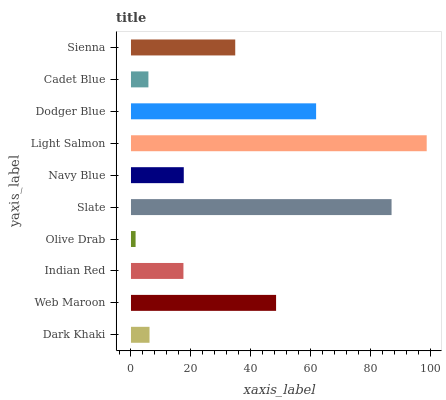Is Olive Drab the minimum?
Answer yes or no. Yes. Is Light Salmon the maximum?
Answer yes or no. Yes. Is Web Maroon the minimum?
Answer yes or no. No. Is Web Maroon the maximum?
Answer yes or no. No. Is Web Maroon greater than Dark Khaki?
Answer yes or no. Yes. Is Dark Khaki less than Web Maroon?
Answer yes or no. Yes. Is Dark Khaki greater than Web Maroon?
Answer yes or no. No. Is Web Maroon less than Dark Khaki?
Answer yes or no. No. Is Sienna the high median?
Answer yes or no. Yes. Is Navy Blue the low median?
Answer yes or no. Yes. Is Slate the high median?
Answer yes or no. No. Is Cadet Blue the low median?
Answer yes or no. No. 